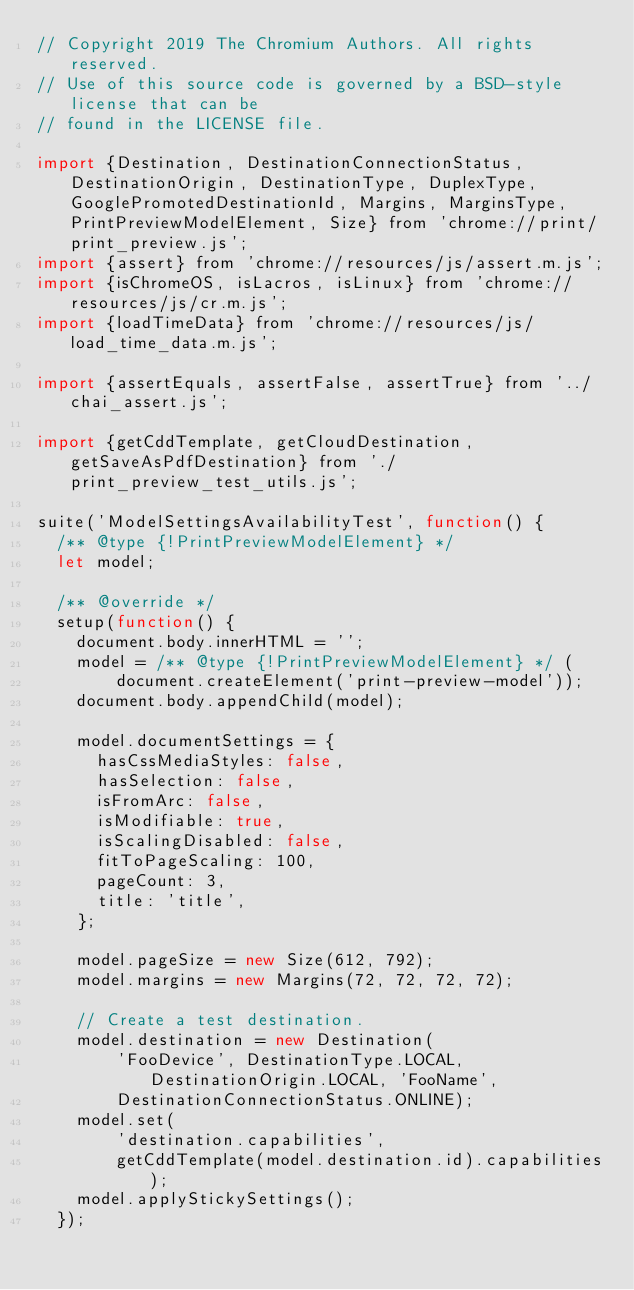Convert code to text. <code><loc_0><loc_0><loc_500><loc_500><_JavaScript_>// Copyright 2019 The Chromium Authors. All rights reserved.
// Use of this source code is governed by a BSD-style license that can be
// found in the LICENSE file.

import {Destination, DestinationConnectionStatus, DestinationOrigin, DestinationType, DuplexType, GooglePromotedDestinationId, Margins, MarginsType, PrintPreviewModelElement, Size} from 'chrome://print/print_preview.js';
import {assert} from 'chrome://resources/js/assert.m.js';
import {isChromeOS, isLacros, isLinux} from 'chrome://resources/js/cr.m.js';
import {loadTimeData} from 'chrome://resources/js/load_time_data.m.js';

import {assertEquals, assertFalse, assertTrue} from '../chai_assert.js';

import {getCddTemplate, getCloudDestination, getSaveAsPdfDestination} from './print_preview_test_utils.js';

suite('ModelSettingsAvailabilityTest', function() {
  /** @type {!PrintPreviewModelElement} */
  let model;

  /** @override */
  setup(function() {
    document.body.innerHTML = '';
    model = /** @type {!PrintPreviewModelElement} */ (
        document.createElement('print-preview-model'));
    document.body.appendChild(model);

    model.documentSettings = {
      hasCssMediaStyles: false,
      hasSelection: false,
      isFromArc: false,
      isModifiable: true,
      isScalingDisabled: false,
      fitToPageScaling: 100,
      pageCount: 3,
      title: 'title',
    };

    model.pageSize = new Size(612, 792);
    model.margins = new Margins(72, 72, 72, 72);

    // Create a test destination.
    model.destination = new Destination(
        'FooDevice', DestinationType.LOCAL, DestinationOrigin.LOCAL, 'FooName',
        DestinationConnectionStatus.ONLINE);
    model.set(
        'destination.capabilities',
        getCddTemplate(model.destination.id).capabilities);
    model.applyStickySettings();
  });
</code> 